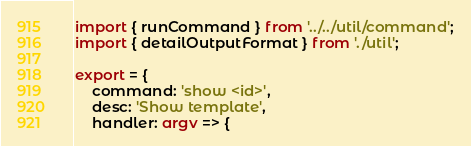Convert code to text. <code><loc_0><loc_0><loc_500><loc_500><_TypeScript_>import { runCommand } from '../../util/command';
import { detailOutputFormat } from './util';

export = {
	command: 'show <id>',
	desc: 'Show template',
	handler: argv => {</code> 